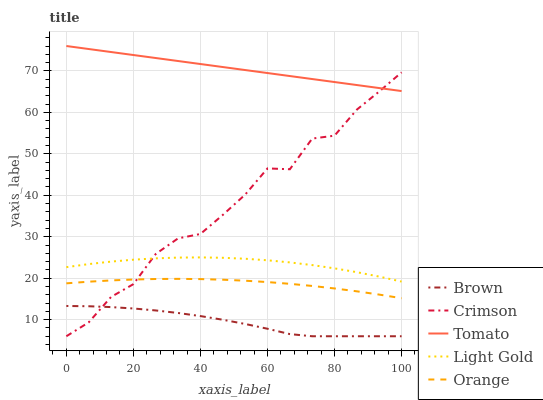Does Brown have the minimum area under the curve?
Answer yes or no. Yes. Does Tomato have the maximum area under the curve?
Answer yes or no. Yes. Does Tomato have the minimum area under the curve?
Answer yes or no. No. Does Brown have the maximum area under the curve?
Answer yes or no. No. Is Tomato the smoothest?
Answer yes or no. Yes. Is Crimson the roughest?
Answer yes or no. Yes. Is Brown the smoothest?
Answer yes or no. No. Is Brown the roughest?
Answer yes or no. No. Does Crimson have the lowest value?
Answer yes or no. Yes. Does Tomato have the lowest value?
Answer yes or no. No. Does Tomato have the highest value?
Answer yes or no. Yes. Does Brown have the highest value?
Answer yes or no. No. Is Orange less than Tomato?
Answer yes or no. Yes. Is Tomato greater than Light Gold?
Answer yes or no. Yes. Does Crimson intersect Tomato?
Answer yes or no. Yes. Is Crimson less than Tomato?
Answer yes or no. No. Is Crimson greater than Tomato?
Answer yes or no. No. Does Orange intersect Tomato?
Answer yes or no. No. 